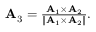<formula> <loc_0><loc_0><loc_500><loc_500>\begin{array} { r } { { A } _ { 3 } = \frac { { A } _ { 1 } \times { A } _ { 2 } } { \| { A } _ { 1 } \times { A } _ { 2 } \| } . } \end{array}</formula> 